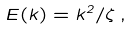Convert formula to latex. <formula><loc_0><loc_0><loc_500><loc_500>E ( k ) = k ^ { 2 } / \zeta \, ,</formula> 